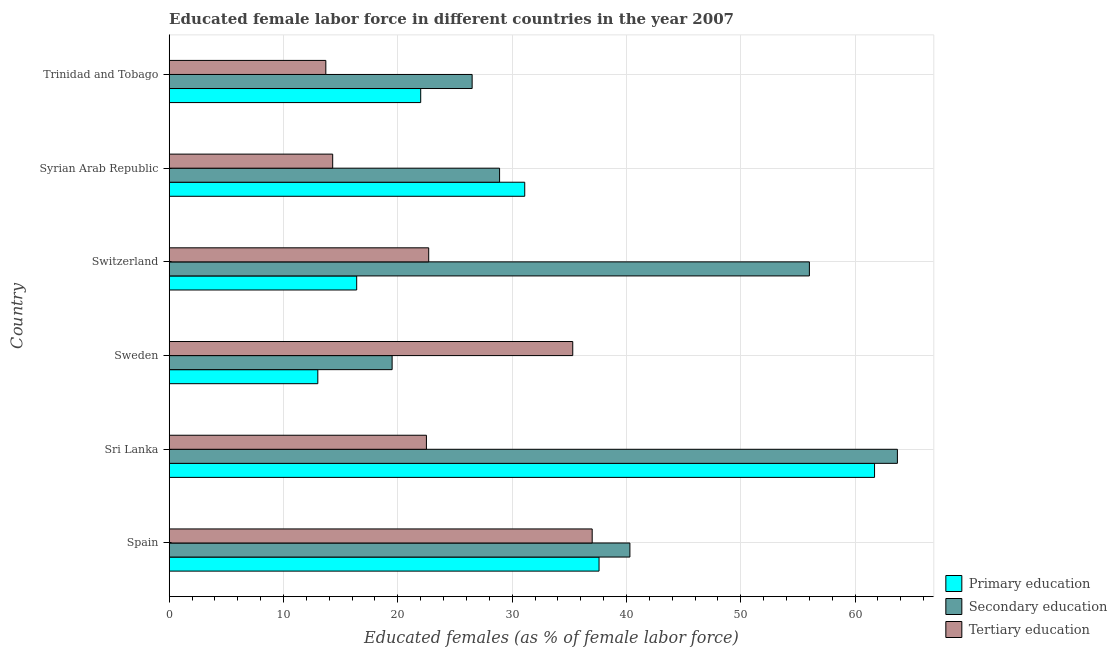How many different coloured bars are there?
Give a very brief answer. 3. How many groups of bars are there?
Make the answer very short. 6. What is the label of the 1st group of bars from the top?
Your answer should be very brief. Trinidad and Tobago. In how many cases, is the number of bars for a given country not equal to the number of legend labels?
Keep it short and to the point. 0. Across all countries, what is the minimum percentage of female labor force who received tertiary education?
Provide a short and direct response. 13.7. In which country was the percentage of female labor force who received primary education maximum?
Ensure brevity in your answer.  Sri Lanka. In which country was the percentage of female labor force who received tertiary education minimum?
Provide a short and direct response. Trinidad and Tobago. What is the total percentage of female labor force who received secondary education in the graph?
Keep it short and to the point. 234.9. What is the difference between the percentage of female labor force who received primary education in Spain and that in Syrian Arab Republic?
Your response must be concise. 6.5. What is the difference between the percentage of female labor force who received secondary education in Sri Lanka and the percentage of female labor force who received primary education in Switzerland?
Your answer should be very brief. 47.3. What is the average percentage of female labor force who received tertiary education per country?
Provide a short and direct response. 24.25. What is the difference between the percentage of female labor force who received tertiary education and percentage of female labor force who received primary education in Sri Lanka?
Give a very brief answer. -39.2. What is the ratio of the percentage of female labor force who received primary education in Spain to that in Sweden?
Your answer should be compact. 2.89. Is the difference between the percentage of female labor force who received primary education in Switzerland and Syrian Arab Republic greater than the difference between the percentage of female labor force who received tertiary education in Switzerland and Syrian Arab Republic?
Provide a succinct answer. No. What is the difference between the highest and the second highest percentage of female labor force who received secondary education?
Your response must be concise. 7.7. What is the difference between the highest and the lowest percentage of female labor force who received primary education?
Offer a terse response. 48.7. What does the 3rd bar from the top in Switzerland represents?
Your response must be concise. Primary education. What does the 2nd bar from the bottom in Switzerland represents?
Keep it short and to the point. Secondary education. Is it the case that in every country, the sum of the percentage of female labor force who received primary education and percentage of female labor force who received secondary education is greater than the percentage of female labor force who received tertiary education?
Keep it short and to the point. No. How many bars are there?
Your answer should be compact. 18. How many countries are there in the graph?
Your response must be concise. 6. What is the difference between two consecutive major ticks on the X-axis?
Your response must be concise. 10. Are the values on the major ticks of X-axis written in scientific E-notation?
Ensure brevity in your answer.  No. Does the graph contain any zero values?
Provide a succinct answer. No. How many legend labels are there?
Your answer should be compact. 3. How are the legend labels stacked?
Your response must be concise. Vertical. What is the title of the graph?
Offer a very short reply. Educated female labor force in different countries in the year 2007. What is the label or title of the X-axis?
Ensure brevity in your answer.  Educated females (as % of female labor force). What is the Educated females (as % of female labor force) of Primary education in Spain?
Your answer should be very brief. 37.6. What is the Educated females (as % of female labor force) in Secondary education in Spain?
Your response must be concise. 40.3. What is the Educated females (as % of female labor force) in Tertiary education in Spain?
Your answer should be very brief. 37. What is the Educated females (as % of female labor force) in Primary education in Sri Lanka?
Your answer should be very brief. 61.7. What is the Educated females (as % of female labor force) in Secondary education in Sri Lanka?
Provide a succinct answer. 63.7. What is the Educated females (as % of female labor force) in Primary education in Sweden?
Provide a short and direct response. 13. What is the Educated females (as % of female labor force) in Tertiary education in Sweden?
Provide a short and direct response. 35.3. What is the Educated females (as % of female labor force) in Primary education in Switzerland?
Your answer should be compact. 16.4. What is the Educated females (as % of female labor force) in Secondary education in Switzerland?
Offer a very short reply. 56. What is the Educated females (as % of female labor force) in Tertiary education in Switzerland?
Offer a very short reply. 22.7. What is the Educated females (as % of female labor force) in Primary education in Syrian Arab Republic?
Your answer should be compact. 31.1. What is the Educated females (as % of female labor force) in Secondary education in Syrian Arab Republic?
Your answer should be very brief. 28.9. What is the Educated females (as % of female labor force) of Tertiary education in Syrian Arab Republic?
Ensure brevity in your answer.  14.3. What is the Educated females (as % of female labor force) in Primary education in Trinidad and Tobago?
Offer a terse response. 22. What is the Educated females (as % of female labor force) in Tertiary education in Trinidad and Tobago?
Your response must be concise. 13.7. Across all countries, what is the maximum Educated females (as % of female labor force) in Primary education?
Provide a short and direct response. 61.7. Across all countries, what is the maximum Educated females (as % of female labor force) in Secondary education?
Your response must be concise. 63.7. Across all countries, what is the minimum Educated females (as % of female labor force) of Tertiary education?
Offer a very short reply. 13.7. What is the total Educated females (as % of female labor force) in Primary education in the graph?
Offer a very short reply. 181.8. What is the total Educated females (as % of female labor force) in Secondary education in the graph?
Keep it short and to the point. 234.9. What is the total Educated females (as % of female labor force) in Tertiary education in the graph?
Your answer should be compact. 145.5. What is the difference between the Educated females (as % of female labor force) in Primary education in Spain and that in Sri Lanka?
Make the answer very short. -24.1. What is the difference between the Educated females (as % of female labor force) of Secondary education in Spain and that in Sri Lanka?
Make the answer very short. -23.4. What is the difference between the Educated females (as % of female labor force) in Primary education in Spain and that in Sweden?
Offer a very short reply. 24.6. What is the difference between the Educated females (as % of female labor force) of Secondary education in Spain and that in Sweden?
Keep it short and to the point. 20.8. What is the difference between the Educated females (as % of female labor force) of Primary education in Spain and that in Switzerland?
Your response must be concise. 21.2. What is the difference between the Educated females (as % of female labor force) in Secondary education in Spain and that in Switzerland?
Your answer should be very brief. -15.7. What is the difference between the Educated females (as % of female labor force) in Tertiary education in Spain and that in Switzerland?
Keep it short and to the point. 14.3. What is the difference between the Educated females (as % of female labor force) of Primary education in Spain and that in Syrian Arab Republic?
Your answer should be compact. 6.5. What is the difference between the Educated females (as % of female labor force) of Tertiary education in Spain and that in Syrian Arab Republic?
Give a very brief answer. 22.7. What is the difference between the Educated females (as % of female labor force) of Tertiary education in Spain and that in Trinidad and Tobago?
Keep it short and to the point. 23.3. What is the difference between the Educated females (as % of female labor force) in Primary education in Sri Lanka and that in Sweden?
Your response must be concise. 48.7. What is the difference between the Educated females (as % of female labor force) in Secondary education in Sri Lanka and that in Sweden?
Your response must be concise. 44.2. What is the difference between the Educated females (as % of female labor force) of Tertiary education in Sri Lanka and that in Sweden?
Your answer should be compact. -12.8. What is the difference between the Educated females (as % of female labor force) of Primary education in Sri Lanka and that in Switzerland?
Provide a short and direct response. 45.3. What is the difference between the Educated females (as % of female labor force) of Tertiary education in Sri Lanka and that in Switzerland?
Provide a succinct answer. -0.2. What is the difference between the Educated females (as % of female labor force) in Primary education in Sri Lanka and that in Syrian Arab Republic?
Offer a very short reply. 30.6. What is the difference between the Educated females (as % of female labor force) of Secondary education in Sri Lanka and that in Syrian Arab Republic?
Your answer should be compact. 34.8. What is the difference between the Educated females (as % of female labor force) of Primary education in Sri Lanka and that in Trinidad and Tobago?
Make the answer very short. 39.7. What is the difference between the Educated females (as % of female labor force) of Secondary education in Sri Lanka and that in Trinidad and Tobago?
Make the answer very short. 37.2. What is the difference between the Educated females (as % of female labor force) of Primary education in Sweden and that in Switzerland?
Your response must be concise. -3.4. What is the difference between the Educated females (as % of female labor force) of Secondary education in Sweden and that in Switzerland?
Offer a very short reply. -36.5. What is the difference between the Educated females (as % of female labor force) of Primary education in Sweden and that in Syrian Arab Republic?
Offer a very short reply. -18.1. What is the difference between the Educated females (as % of female labor force) in Tertiary education in Sweden and that in Syrian Arab Republic?
Offer a very short reply. 21. What is the difference between the Educated females (as % of female labor force) in Secondary education in Sweden and that in Trinidad and Tobago?
Offer a very short reply. -7. What is the difference between the Educated females (as % of female labor force) of Tertiary education in Sweden and that in Trinidad and Tobago?
Ensure brevity in your answer.  21.6. What is the difference between the Educated females (as % of female labor force) in Primary education in Switzerland and that in Syrian Arab Republic?
Make the answer very short. -14.7. What is the difference between the Educated females (as % of female labor force) in Secondary education in Switzerland and that in Syrian Arab Republic?
Your answer should be compact. 27.1. What is the difference between the Educated females (as % of female labor force) in Tertiary education in Switzerland and that in Syrian Arab Republic?
Keep it short and to the point. 8.4. What is the difference between the Educated females (as % of female labor force) of Primary education in Switzerland and that in Trinidad and Tobago?
Your answer should be very brief. -5.6. What is the difference between the Educated females (as % of female labor force) in Secondary education in Switzerland and that in Trinidad and Tobago?
Your response must be concise. 29.5. What is the difference between the Educated females (as % of female labor force) of Secondary education in Syrian Arab Republic and that in Trinidad and Tobago?
Your response must be concise. 2.4. What is the difference between the Educated females (as % of female labor force) in Tertiary education in Syrian Arab Republic and that in Trinidad and Tobago?
Your response must be concise. 0.6. What is the difference between the Educated females (as % of female labor force) in Primary education in Spain and the Educated females (as % of female labor force) in Secondary education in Sri Lanka?
Provide a short and direct response. -26.1. What is the difference between the Educated females (as % of female labor force) in Primary education in Spain and the Educated females (as % of female labor force) in Tertiary education in Sri Lanka?
Offer a terse response. 15.1. What is the difference between the Educated females (as % of female labor force) of Secondary education in Spain and the Educated females (as % of female labor force) of Tertiary education in Sri Lanka?
Offer a very short reply. 17.8. What is the difference between the Educated females (as % of female labor force) in Secondary education in Spain and the Educated females (as % of female labor force) in Tertiary education in Sweden?
Provide a succinct answer. 5. What is the difference between the Educated females (as % of female labor force) of Primary education in Spain and the Educated females (as % of female labor force) of Secondary education in Switzerland?
Provide a succinct answer. -18.4. What is the difference between the Educated females (as % of female labor force) of Primary education in Spain and the Educated females (as % of female labor force) of Tertiary education in Switzerland?
Give a very brief answer. 14.9. What is the difference between the Educated females (as % of female labor force) in Secondary education in Spain and the Educated females (as % of female labor force) in Tertiary education in Switzerland?
Your response must be concise. 17.6. What is the difference between the Educated females (as % of female labor force) in Primary education in Spain and the Educated females (as % of female labor force) in Tertiary education in Syrian Arab Republic?
Give a very brief answer. 23.3. What is the difference between the Educated females (as % of female labor force) in Secondary education in Spain and the Educated females (as % of female labor force) in Tertiary education in Syrian Arab Republic?
Offer a terse response. 26. What is the difference between the Educated females (as % of female labor force) of Primary education in Spain and the Educated females (as % of female labor force) of Tertiary education in Trinidad and Tobago?
Your answer should be very brief. 23.9. What is the difference between the Educated females (as % of female labor force) of Secondary education in Spain and the Educated females (as % of female labor force) of Tertiary education in Trinidad and Tobago?
Your response must be concise. 26.6. What is the difference between the Educated females (as % of female labor force) of Primary education in Sri Lanka and the Educated females (as % of female labor force) of Secondary education in Sweden?
Give a very brief answer. 42.2. What is the difference between the Educated females (as % of female labor force) of Primary education in Sri Lanka and the Educated females (as % of female labor force) of Tertiary education in Sweden?
Offer a terse response. 26.4. What is the difference between the Educated females (as % of female labor force) of Secondary education in Sri Lanka and the Educated females (as % of female labor force) of Tertiary education in Sweden?
Your response must be concise. 28.4. What is the difference between the Educated females (as % of female labor force) of Primary education in Sri Lanka and the Educated females (as % of female labor force) of Secondary education in Switzerland?
Keep it short and to the point. 5.7. What is the difference between the Educated females (as % of female labor force) in Secondary education in Sri Lanka and the Educated females (as % of female labor force) in Tertiary education in Switzerland?
Keep it short and to the point. 41. What is the difference between the Educated females (as % of female labor force) of Primary education in Sri Lanka and the Educated females (as % of female labor force) of Secondary education in Syrian Arab Republic?
Your response must be concise. 32.8. What is the difference between the Educated females (as % of female labor force) in Primary education in Sri Lanka and the Educated females (as % of female labor force) in Tertiary education in Syrian Arab Republic?
Your answer should be compact. 47.4. What is the difference between the Educated females (as % of female labor force) of Secondary education in Sri Lanka and the Educated females (as % of female labor force) of Tertiary education in Syrian Arab Republic?
Offer a very short reply. 49.4. What is the difference between the Educated females (as % of female labor force) of Primary education in Sri Lanka and the Educated females (as % of female labor force) of Secondary education in Trinidad and Tobago?
Make the answer very short. 35.2. What is the difference between the Educated females (as % of female labor force) of Secondary education in Sri Lanka and the Educated females (as % of female labor force) of Tertiary education in Trinidad and Tobago?
Offer a terse response. 50. What is the difference between the Educated females (as % of female labor force) in Primary education in Sweden and the Educated females (as % of female labor force) in Secondary education in Switzerland?
Make the answer very short. -43. What is the difference between the Educated females (as % of female labor force) in Primary education in Sweden and the Educated females (as % of female labor force) in Tertiary education in Switzerland?
Provide a short and direct response. -9.7. What is the difference between the Educated females (as % of female labor force) of Primary education in Sweden and the Educated females (as % of female labor force) of Secondary education in Syrian Arab Republic?
Give a very brief answer. -15.9. What is the difference between the Educated females (as % of female labor force) in Primary education in Sweden and the Educated females (as % of female labor force) in Secondary education in Trinidad and Tobago?
Your response must be concise. -13.5. What is the difference between the Educated females (as % of female labor force) of Secondary education in Sweden and the Educated females (as % of female labor force) of Tertiary education in Trinidad and Tobago?
Your answer should be very brief. 5.8. What is the difference between the Educated females (as % of female labor force) in Secondary education in Switzerland and the Educated females (as % of female labor force) in Tertiary education in Syrian Arab Republic?
Provide a short and direct response. 41.7. What is the difference between the Educated females (as % of female labor force) in Primary education in Switzerland and the Educated females (as % of female labor force) in Tertiary education in Trinidad and Tobago?
Offer a very short reply. 2.7. What is the difference between the Educated females (as % of female labor force) in Secondary education in Switzerland and the Educated females (as % of female labor force) in Tertiary education in Trinidad and Tobago?
Offer a terse response. 42.3. What is the difference between the Educated females (as % of female labor force) in Primary education in Syrian Arab Republic and the Educated females (as % of female labor force) in Secondary education in Trinidad and Tobago?
Offer a very short reply. 4.6. What is the average Educated females (as % of female labor force) in Primary education per country?
Offer a very short reply. 30.3. What is the average Educated females (as % of female labor force) of Secondary education per country?
Provide a short and direct response. 39.15. What is the average Educated females (as % of female labor force) of Tertiary education per country?
Your answer should be compact. 24.25. What is the difference between the Educated females (as % of female labor force) in Primary education and Educated females (as % of female labor force) in Tertiary education in Sri Lanka?
Keep it short and to the point. 39.2. What is the difference between the Educated females (as % of female labor force) of Secondary education and Educated females (as % of female labor force) of Tertiary education in Sri Lanka?
Give a very brief answer. 41.2. What is the difference between the Educated females (as % of female labor force) of Primary education and Educated females (as % of female labor force) of Secondary education in Sweden?
Your answer should be very brief. -6.5. What is the difference between the Educated females (as % of female labor force) in Primary education and Educated females (as % of female labor force) in Tertiary education in Sweden?
Your answer should be compact. -22.3. What is the difference between the Educated females (as % of female labor force) of Secondary education and Educated females (as % of female labor force) of Tertiary education in Sweden?
Your answer should be very brief. -15.8. What is the difference between the Educated females (as % of female labor force) of Primary education and Educated females (as % of female labor force) of Secondary education in Switzerland?
Your response must be concise. -39.6. What is the difference between the Educated females (as % of female labor force) in Secondary education and Educated females (as % of female labor force) in Tertiary education in Switzerland?
Ensure brevity in your answer.  33.3. What is the difference between the Educated females (as % of female labor force) of Primary education and Educated females (as % of female labor force) of Secondary education in Syrian Arab Republic?
Your answer should be compact. 2.2. What is the difference between the Educated females (as % of female labor force) in Primary education and Educated females (as % of female labor force) in Tertiary education in Syrian Arab Republic?
Ensure brevity in your answer.  16.8. What is the difference between the Educated females (as % of female labor force) of Primary education and Educated females (as % of female labor force) of Secondary education in Trinidad and Tobago?
Your response must be concise. -4.5. What is the difference between the Educated females (as % of female labor force) in Primary education and Educated females (as % of female labor force) in Tertiary education in Trinidad and Tobago?
Make the answer very short. 8.3. What is the ratio of the Educated females (as % of female labor force) of Primary education in Spain to that in Sri Lanka?
Offer a very short reply. 0.61. What is the ratio of the Educated females (as % of female labor force) in Secondary education in Spain to that in Sri Lanka?
Give a very brief answer. 0.63. What is the ratio of the Educated females (as % of female labor force) of Tertiary education in Spain to that in Sri Lanka?
Your answer should be very brief. 1.64. What is the ratio of the Educated females (as % of female labor force) of Primary education in Spain to that in Sweden?
Your answer should be compact. 2.89. What is the ratio of the Educated females (as % of female labor force) in Secondary education in Spain to that in Sweden?
Your answer should be compact. 2.07. What is the ratio of the Educated females (as % of female labor force) of Tertiary education in Spain to that in Sweden?
Your response must be concise. 1.05. What is the ratio of the Educated females (as % of female labor force) of Primary education in Spain to that in Switzerland?
Offer a very short reply. 2.29. What is the ratio of the Educated females (as % of female labor force) of Secondary education in Spain to that in Switzerland?
Give a very brief answer. 0.72. What is the ratio of the Educated females (as % of female labor force) in Tertiary education in Spain to that in Switzerland?
Give a very brief answer. 1.63. What is the ratio of the Educated females (as % of female labor force) in Primary education in Spain to that in Syrian Arab Republic?
Keep it short and to the point. 1.21. What is the ratio of the Educated females (as % of female labor force) of Secondary education in Spain to that in Syrian Arab Republic?
Give a very brief answer. 1.39. What is the ratio of the Educated females (as % of female labor force) in Tertiary education in Spain to that in Syrian Arab Republic?
Your answer should be very brief. 2.59. What is the ratio of the Educated females (as % of female labor force) in Primary education in Spain to that in Trinidad and Tobago?
Offer a very short reply. 1.71. What is the ratio of the Educated females (as % of female labor force) in Secondary education in Spain to that in Trinidad and Tobago?
Ensure brevity in your answer.  1.52. What is the ratio of the Educated females (as % of female labor force) of Tertiary education in Spain to that in Trinidad and Tobago?
Make the answer very short. 2.7. What is the ratio of the Educated females (as % of female labor force) in Primary education in Sri Lanka to that in Sweden?
Provide a succinct answer. 4.75. What is the ratio of the Educated females (as % of female labor force) of Secondary education in Sri Lanka to that in Sweden?
Give a very brief answer. 3.27. What is the ratio of the Educated females (as % of female labor force) in Tertiary education in Sri Lanka to that in Sweden?
Offer a terse response. 0.64. What is the ratio of the Educated females (as % of female labor force) in Primary education in Sri Lanka to that in Switzerland?
Provide a succinct answer. 3.76. What is the ratio of the Educated females (as % of female labor force) of Secondary education in Sri Lanka to that in Switzerland?
Offer a very short reply. 1.14. What is the ratio of the Educated females (as % of female labor force) in Primary education in Sri Lanka to that in Syrian Arab Republic?
Offer a very short reply. 1.98. What is the ratio of the Educated females (as % of female labor force) of Secondary education in Sri Lanka to that in Syrian Arab Republic?
Your answer should be very brief. 2.2. What is the ratio of the Educated females (as % of female labor force) in Tertiary education in Sri Lanka to that in Syrian Arab Republic?
Ensure brevity in your answer.  1.57. What is the ratio of the Educated females (as % of female labor force) in Primary education in Sri Lanka to that in Trinidad and Tobago?
Ensure brevity in your answer.  2.8. What is the ratio of the Educated females (as % of female labor force) of Secondary education in Sri Lanka to that in Trinidad and Tobago?
Ensure brevity in your answer.  2.4. What is the ratio of the Educated females (as % of female labor force) in Tertiary education in Sri Lanka to that in Trinidad and Tobago?
Keep it short and to the point. 1.64. What is the ratio of the Educated females (as % of female labor force) in Primary education in Sweden to that in Switzerland?
Provide a short and direct response. 0.79. What is the ratio of the Educated females (as % of female labor force) in Secondary education in Sweden to that in Switzerland?
Ensure brevity in your answer.  0.35. What is the ratio of the Educated females (as % of female labor force) of Tertiary education in Sweden to that in Switzerland?
Your response must be concise. 1.56. What is the ratio of the Educated females (as % of female labor force) of Primary education in Sweden to that in Syrian Arab Republic?
Ensure brevity in your answer.  0.42. What is the ratio of the Educated females (as % of female labor force) in Secondary education in Sweden to that in Syrian Arab Republic?
Offer a terse response. 0.67. What is the ratio of the Educated females (as % of female labor force) of Tertiary education in Sweden to that in Syrian Arab Republic?
Offer a terse response. 2.47. What is the ratio of the Educated females (as % of female labor force) of Primary education in Sweden to that in Trinidad and Tobago?
Your response must be concise. 0.59. What is the ratio of the Educated females (as % of female labor force) in Secondary education in Sweden to that in Trinidad and Tobago?
Your response must be concise. 0.74. What is the ratio of the Educated females (as % of female labor force) in Tertiary education in Sweden to that in Trinidad and Tobago?
Ensure brevity in your answer.  2.58. What is the ratio of the Educated females (as % of female labor force) of Primary education in Switzerland to that in Syrian Arab Republic?
Offer a terse response. 0.53. What is the ratio of the Educated females (as % of female labor force) in Secondary education in Switzerland to that in Syrian Arab Republic?
Provide a succinct answer. 1.94. What is the ratio of the Educated females (as % of female labor force) in Tertiary education in Switzerland to that in Syrian Arab Republic?
Your answer should be very brief. 1.59. What is the ratio of the Educated females (as % of female labor force) of Primary education in Switzerland to that in Trinidad and Tobago?
Your response must be concise. 0.75. What is the ratio of the Educated females (as % of female labor force) in Secondary education in Switzerland to that in Trinidad and Tobago?
Give a very brief answer. 2.11. What is the ratio of the Educated females (as % of female labor force) in Tertiary education in Switzerland to that in Trinidad and Tobago?
Your answer should be very brief. 1.66. What is the ratio of the Educated females (as % of female labor force) of Primary education in Syrian Arab Republic to that in Trinidad and Tobago?
Make the answer very short. 1.41. What is the ratio of the Educated females (as % of female labor force) in Secondary education in Syrian Arab Republic to that in Trinidad and Tobago?
Offer a terse response. 1.09. What is the ratio of the Educated females (as % of female labor force) of Tertiary education in Syrian Arab Republic to that in Trinidad and Tobago?
Ensure brevity in your answer.  1.04. What is the difference between the highest and the second highest Educated females (as % of female labor force) in Primary education?
Provide a succinct answer. 24.1. What is the difference between the highest and the second highest Educated females (as % of female labor force) in Secondary education?
Keep it short and to the point. 7.7. What is the difference between the highest and the lowest Educated females (as % of female labor force) in Primary education?
Offer a terse response. 48.7. What is the difference between the highest and the lowest Educated females (as % of female labor force) of Secondary education?
Make the answer very short. 44.2. What is the difference between the highest and the lowest Educated females (as % of female labor force) in Tertiary education?
Offer a terse response. 23.3. 